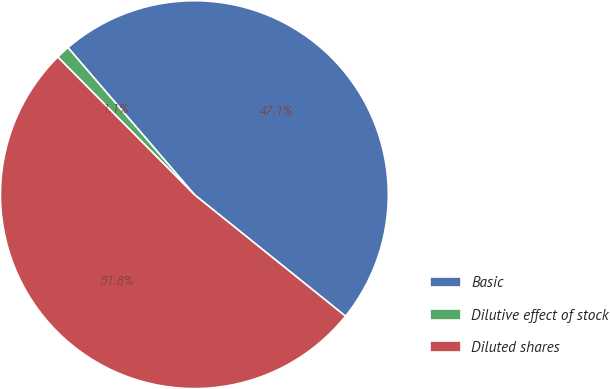<chart> <loc_0><loc_0><loc_500><loc_500><pie_chart><fcel>Basic<fcel>Dilutive effect of stock<fcel>Diluted shares<nl><fcel>47.08%<fcel>1.14%<fcel>51.78%<nl></chart> 